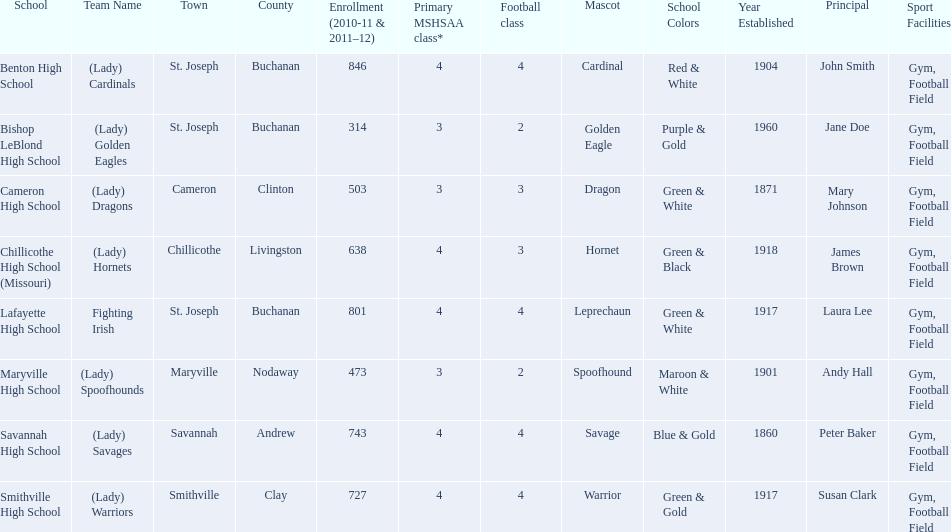What schools are located in st. joseph? Benton High School, Bishop LeBlond High School, Lafayette High School. Which st. joseph schools have more then 800 enrollment  for 2010-11 7 2011-12? Benton High School, Lafayette High School. What is the name of the st. joseph school with 800 or more enrollment's team names is a not a (lady)? Lafayette High School. 